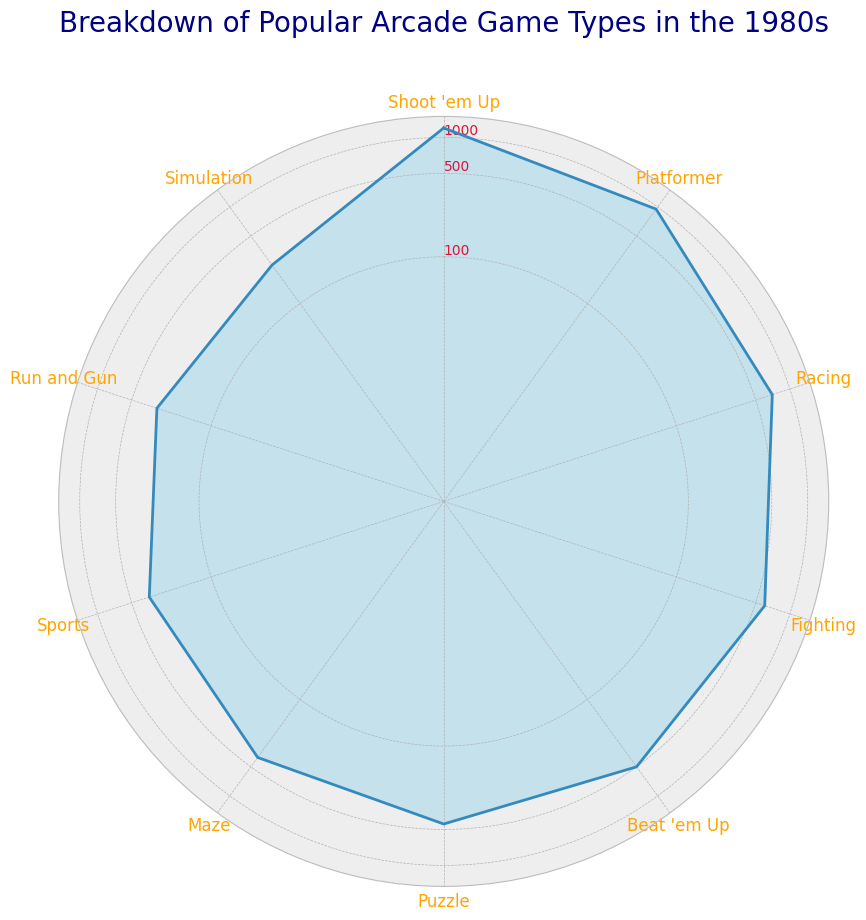What's the arcade game type with the highest number of machines? The highest point on the radar chart shows the category "Shoot 'em Up" with 1200 machines.
Answer: Shoot 'em Up Which arcade game type has the least number of machines, and how many does it have? The lowest point on the radar chart shows the category "Simulation" with 250 machines.
Answer: Simulation, 250 What is the total number of machines for the top three arcade game types? The top three categories by number of machines are "Shoot 'em Up" (1200), "Platformer" (950), and "Racing" (700). Adding these values: 1200 + 950 + 700 = 2850.
Answer: 2850 How do the number of machines for "Sports" and "Puzzle" arcades compare? "Puzzle" has 450 machines, while "Sports" has 350 machines. 450 is greater than 350.
Answer: Puzzle has more machines than Sports What's the difference in the number of machines between "Beat 'em Up" and "Run and Gun"? "Beat 'em Up" has 500 machines, and "Run and Gun" has 300 machines. The difference is 500 - 300 = 200 machines.
Answer: 200 Which game types fall below 500 machines and how many are they? The game types below 500 machines are "Puzzle" (450), "Maze" (400), "Sports" (350), "Run and Gun" (300), and "Simulation" (250). There are 5 game types.
Answer: 5 Is the number of "Fighting" arcade machines closer to the number of "Racing" or "Beat 'em Up" machines? "Fighting" has 600 machines, "Racing" has 700 machines, and "Beat 'em Up" has 500 machines. The difference between "Fighting" and "Racing" is 100, and the difference between "Fighting" and "Beat 'em Up" is also 100.
Answer: Both are equally close What is the average number of machines across all arcade game types? Sum of the machine numbers is 1200 + 950 + 700 + 600 + 500 + 450 + 400 + 350 + 300 + 250 = 5700. The total number of categories is 10. The average is 5700/10 = 570 machines.
Answer: 570 What is the median number of arcade machines and for which category does it occur? The sorted numbers are 250, 300, 350, 400, 450, 500, 600, 700, 950, 1200. The median is the average of the 5th and 6th values: (450 + 500) / 2 = 475 machines. It lies between "Puzzle" and "Beat 'em Up".
Answer: 475, between Puzzle and Beat 'em Up Are there more game types above or below 450 machines, and by how many? Game types above 450 machines are "Shoot 'em Up", "Platformer", "Racing", "Fighting", "Beat 'em Up" (5 types). Game types below 450 machines are "Puzzle", "Maze", "Sports", "Run and Gun", "Simulation" (5 types). 5 - 5 = 0, so they are equal.
Answer: Neither, they are equal 